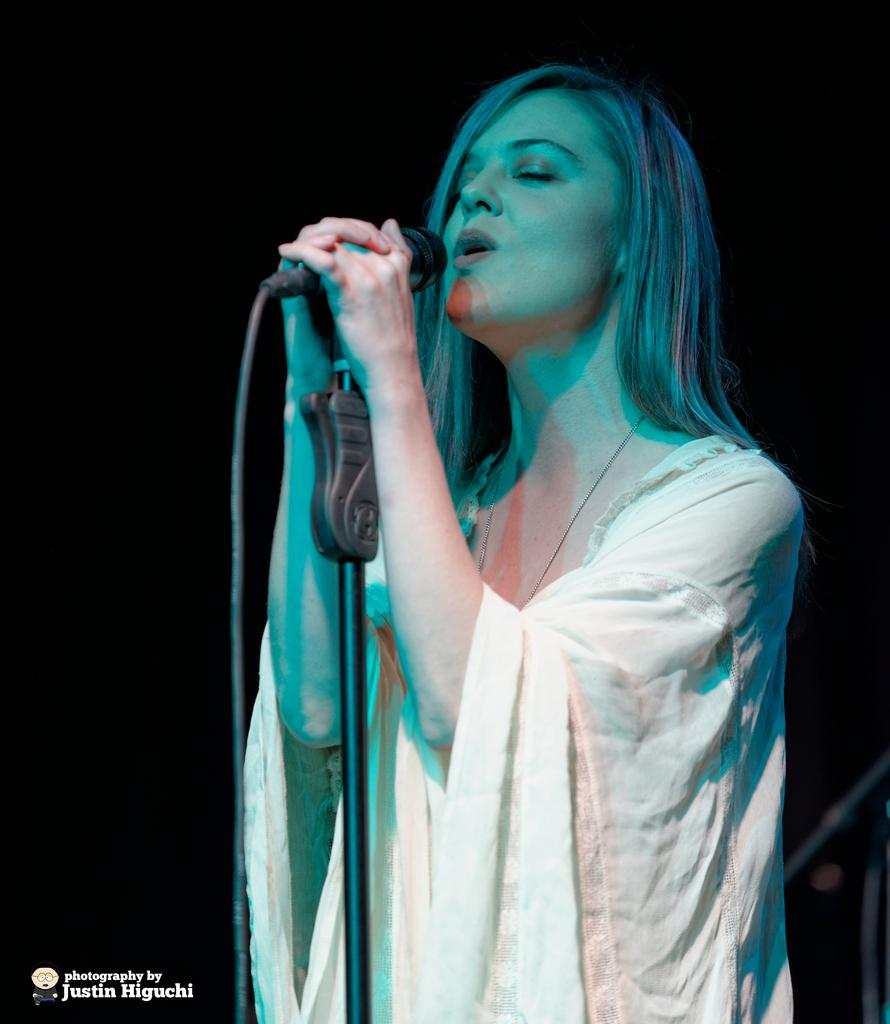What is the woman in the image doing? The woman is singing in the image. What is the woman holding while singing? The woman is holding a microphone. Can you describe the woman's hair in the image? The woman has short hair. What is the woman wearing in the image? The woman is wearing a white dress. What type of stove can be seen in the background of the image? There is no stove present in the image. How many cubs are visible with the woman in the image? There are no cubs present in the image. 